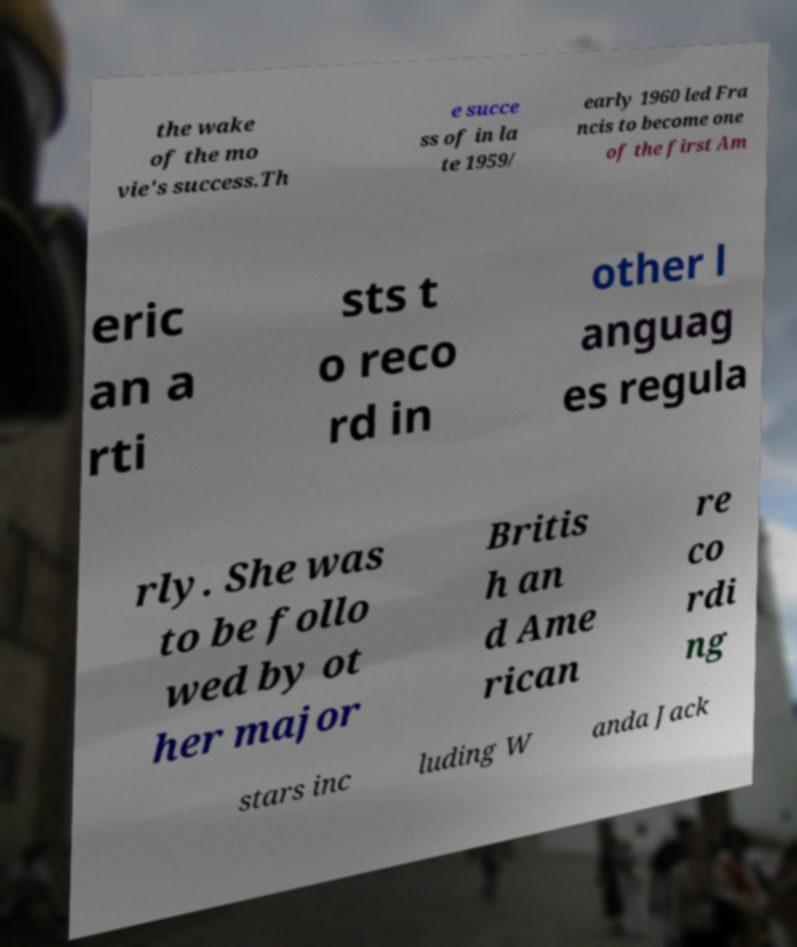There's text embedded in this image that I need extracted. Can you transcribe it verbatim? the wake of the mo vie's success.Th e succe ss of in la te 1959/ early 1960 led Fra ncis to become one of the first Am eric an a rti sts t o reco rd in other l anguag es regula rly. She was to be follo wed by ot her major Britis h an d Ame rican re co rdi ng stars inc luding W anda Jack 